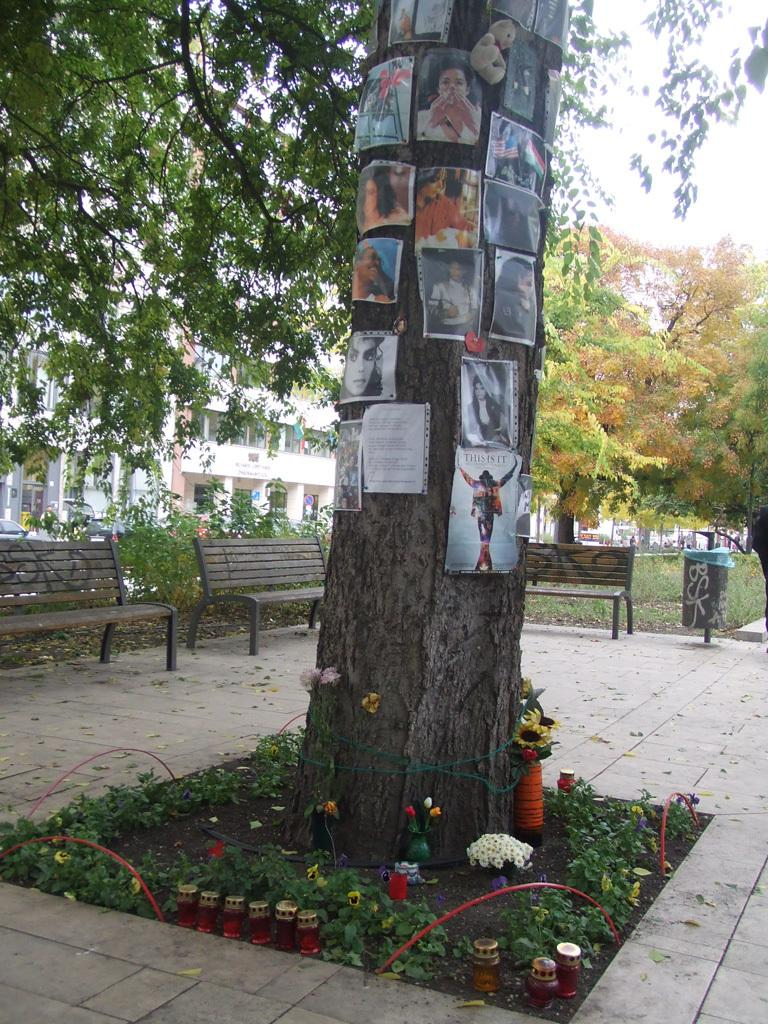What is the main object in the image? There is a tree trunk in the image. What is attached to the tree trunk? There are photos on the tree trunk. What type of natural environment is visible in the image? There are trees visible in the image. What type of seating is present in the image? There are benches in the image. What type of pleasure can be seen on the board in the image? There is no board or pleasure present in the image; it features a tree trunk with photos and benches. 